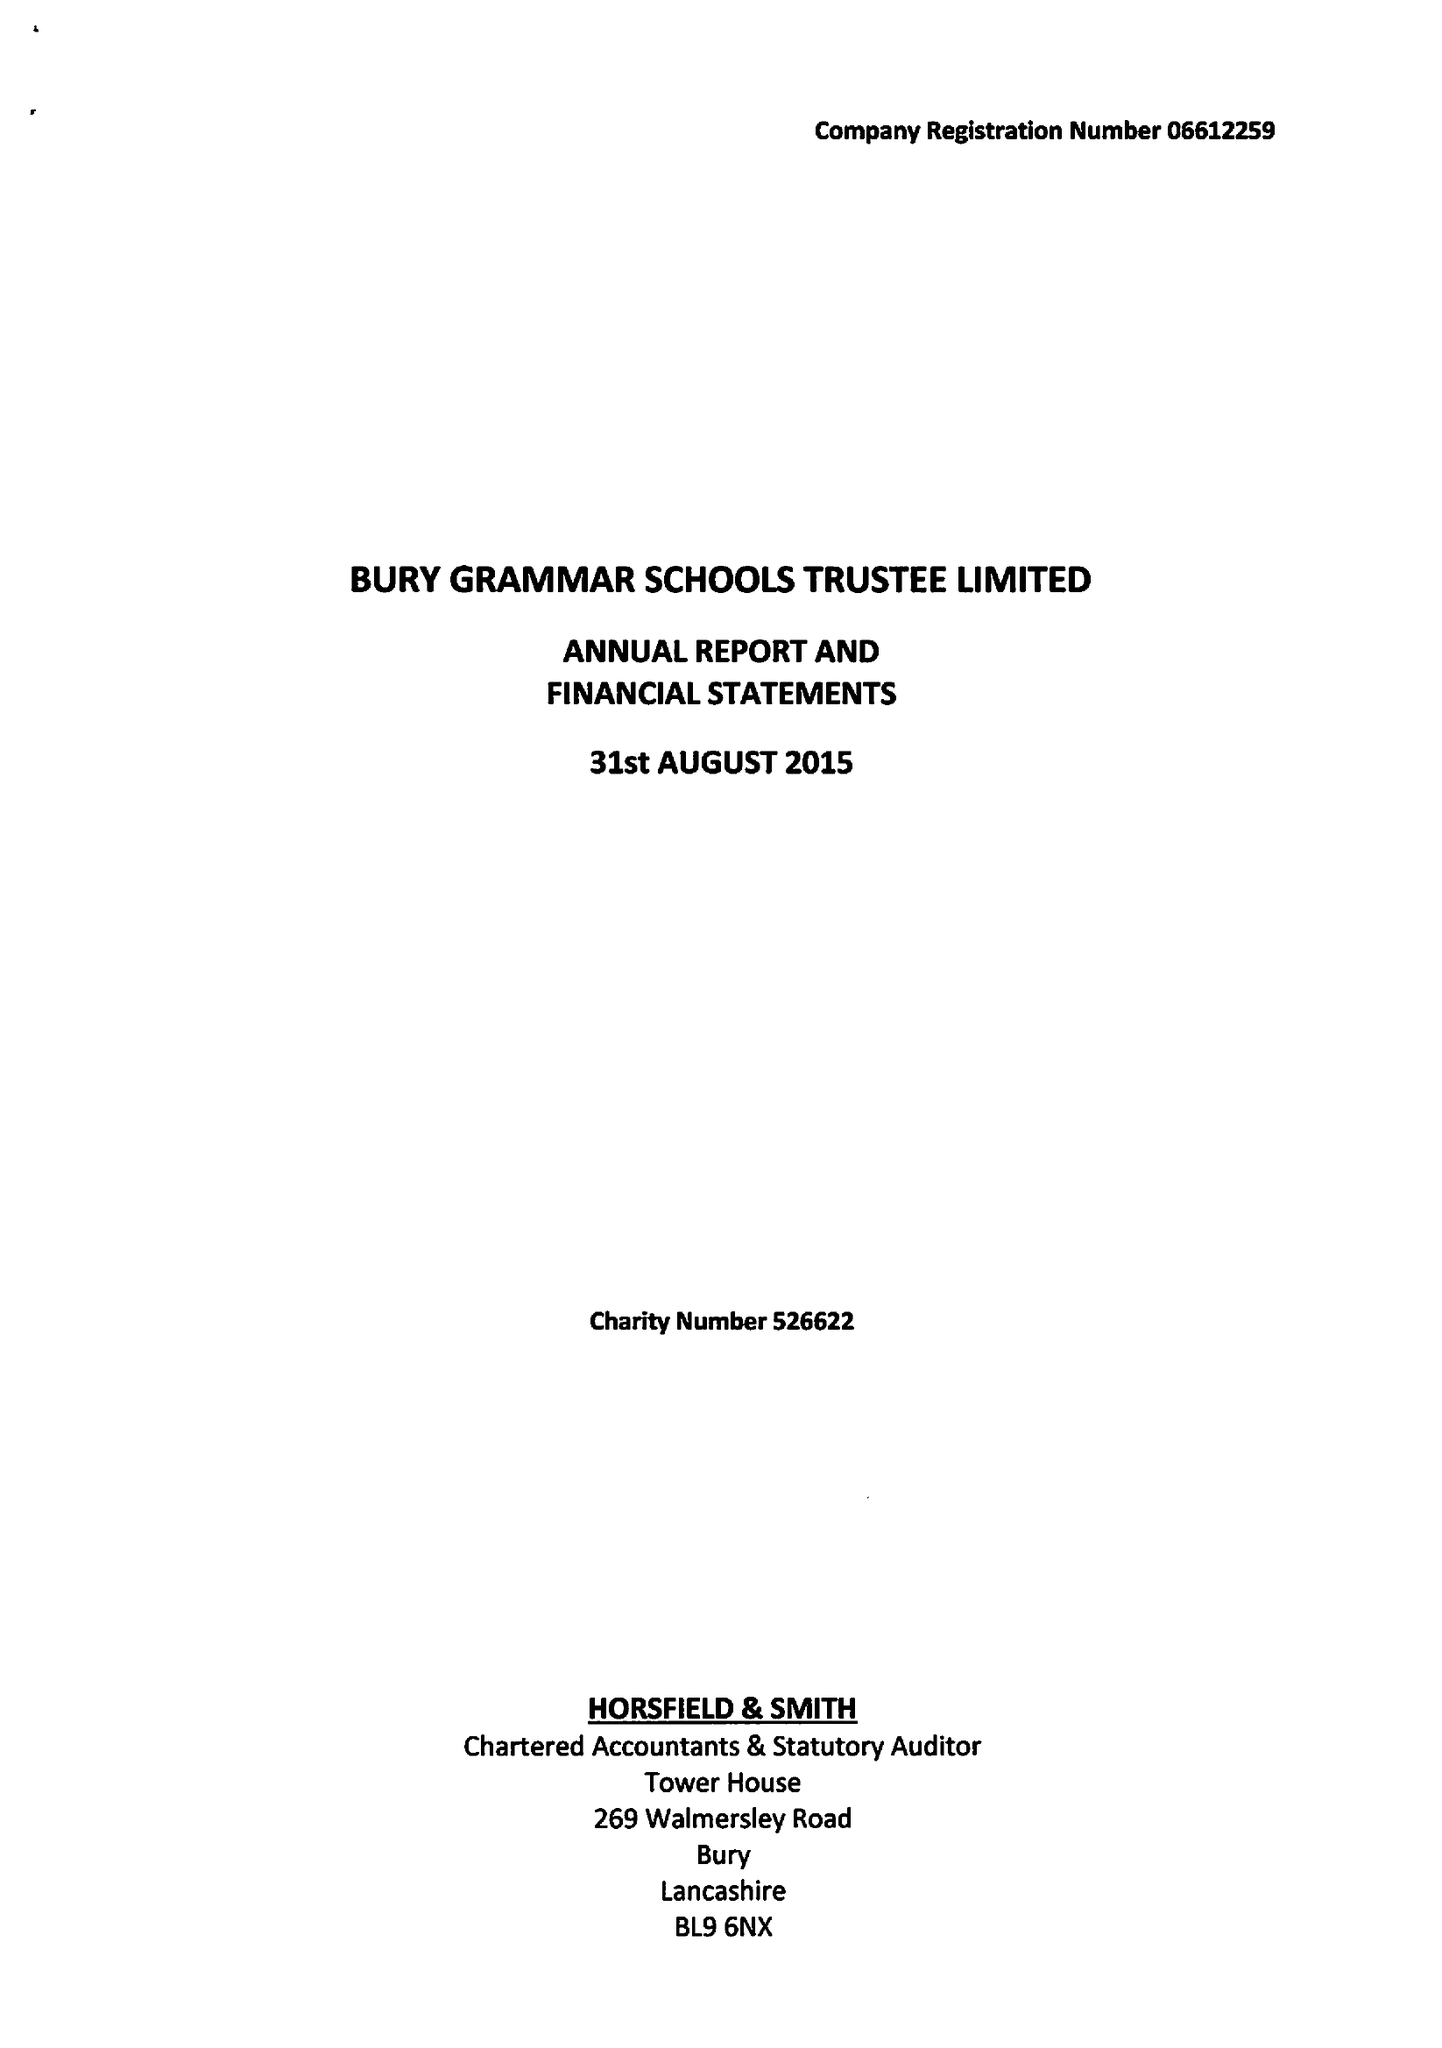What is the value for the address__postcode?
Answer the question using a single word or phrase. BL9 0HG 